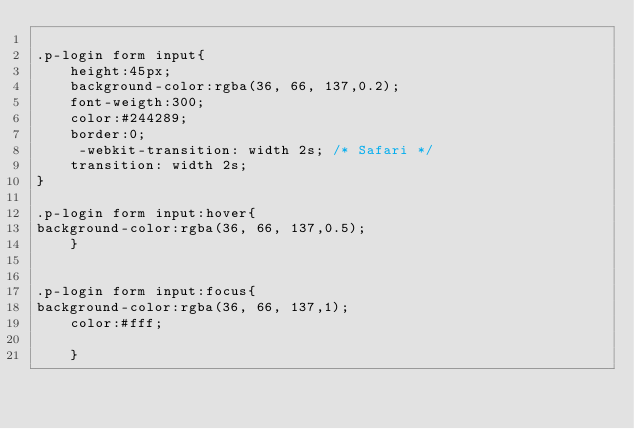Convert code to text. <code><loc_0><loc_0><loc_500><loc_500><_CSS_>
.p-login form input{
	height:45px;
	background-color:rgba(36, 66, 137,0.2);
	font-weigth:300;
	color:#244289;
	border:0;
	 -webkit-transition: width 2s; /* Safari */
    transition: width 2s;
}

.p-login form input:hover{
background-color:rgba(36, 66, 137,0.5);
	}


.p-login form input:focus{
background-color:rgba(36, 66, 137,1);
	color:#fff;

	}



</code> 